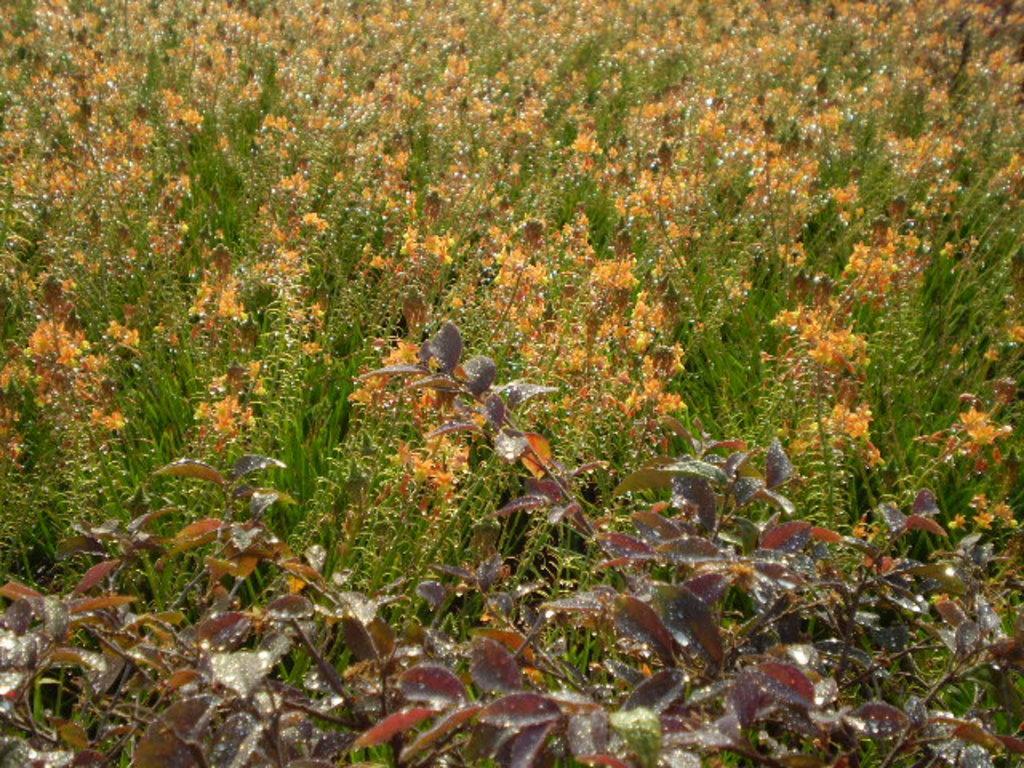Describe this image in one or two sentences. In this image I can see a crop, there are some leaves and flowers visible in the middle. 